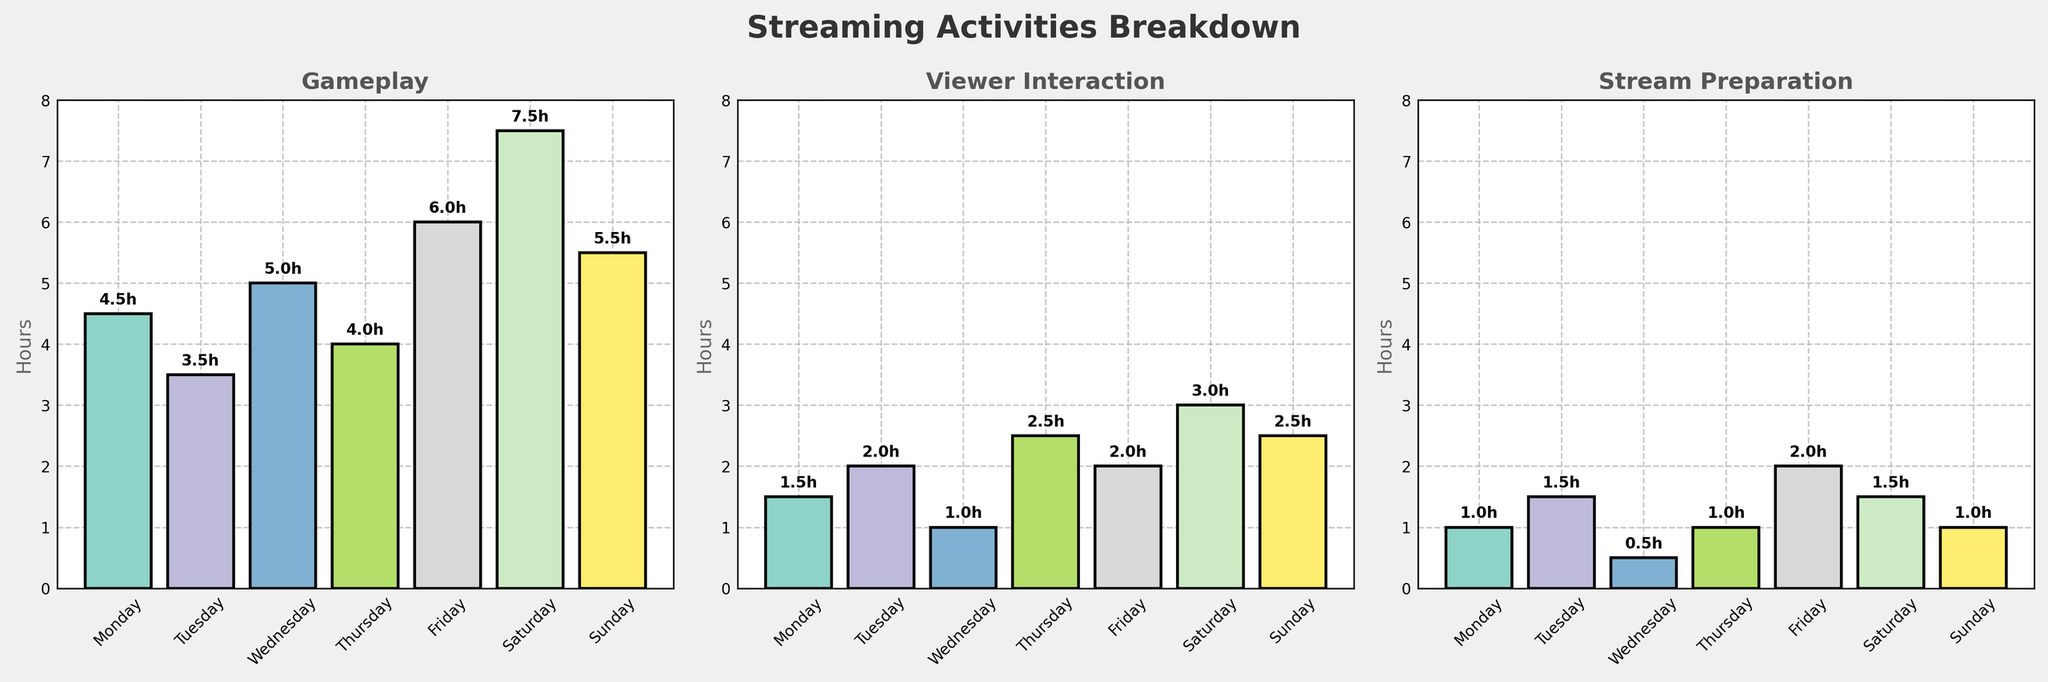What's the title of the figure? The figure has a title at the top which is in bold and larger font size than other text elements. It reads 'Streaming Activities Breakdown'.
Answer: Streaming Activities Breakdown On which day is the maximum time spent on gameplay? Look at the 'Gameplay' subplot and identify the bar that is the tallest. Saturday's bar is the tallest representing 7.5 hours.
Answer: Saturday Which activity has the highest number of hours on Friday and what is the value? Look at the bars for Friday across all three subplots. The 'Gameplay' bar is the tallest on Friday representing 6.0 hours.
Answer: Gameplay, 6.0 hours What's the total time spent on Viewer Interaction over the week? Add the 'Viewer Interaction' values from all days (1.5 + 2.0 + 1.0 + 2.5 + 2.0 + 3.0 + 2.5). The total is 14.5 hours.
Answer: 14.5 hours What's the average time spent on Stream Preparation per day? Add the 'Stream Preparation' values from all days and divide by 7 (1.0 + 1.5 + 0.5 + 1.0 + 2.0 + 1.5 + 1.0 = 8.5). The average is 8.5/7 ≈ 1.21 hours.
Answer: 1.21 hours Which days have more Viewer Interaction time than Stream Preparation time? Compare the values for 'Viewer Interaction' and 'Stream Preparation' for all days. Tuesday (2.0 vs. 1.5), Thursday (2.5 vs. 1.0), Friday (2.0 vs. 2.0), Saturday (3.0 vs. 1.5), and Sunday (2.5 vs. 1.0).
Answer: Tuesday, Thursday, Saturday, Sunday What's the overall highest single activity time slot, and what day is it on? Review all the bars in the subplots. The highest single activity time slot is Gameplay on Saturday with 7.5 hours.
Answer: Gameplay on Saturday, 7.5 hours How does the 'Gameplay' hours trend throughout the week? Examine the heights of the 'Gameplay' bars from Monday to Sunday. The values are 4.5, 3.5, 5.0, 4.0, 6.0, 7.5, and 5.5 showing an increasing trend midweek and peaking on Saturday.
Answer: Increasing midweek, peaks on Saturday Which day has the least amount of Streaming Preparation time, and what is the value? Look for the shortest bar in the 'Stream Preparation' subplot. Wednesday has the least amount of Streaming Preparation time with 0.5 hours.
Answer: Wednesday, 0.5 hours Is there any day where all activities sum up to exactly 8 hours? Calculate the total hours for all activities for each day and check if any sum up to 8 hours. Only Tuesday sums to 8 hours (3.5 + 2.0 + 1.5 + 1).
Answer: Tuesday 